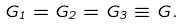Convert formula to latex. <formula><loc_0><loc_0><loc_500><loc_500>G _ { 1 } = G _ { 2 } = G _ { 3 } \equiv G .</formula> 